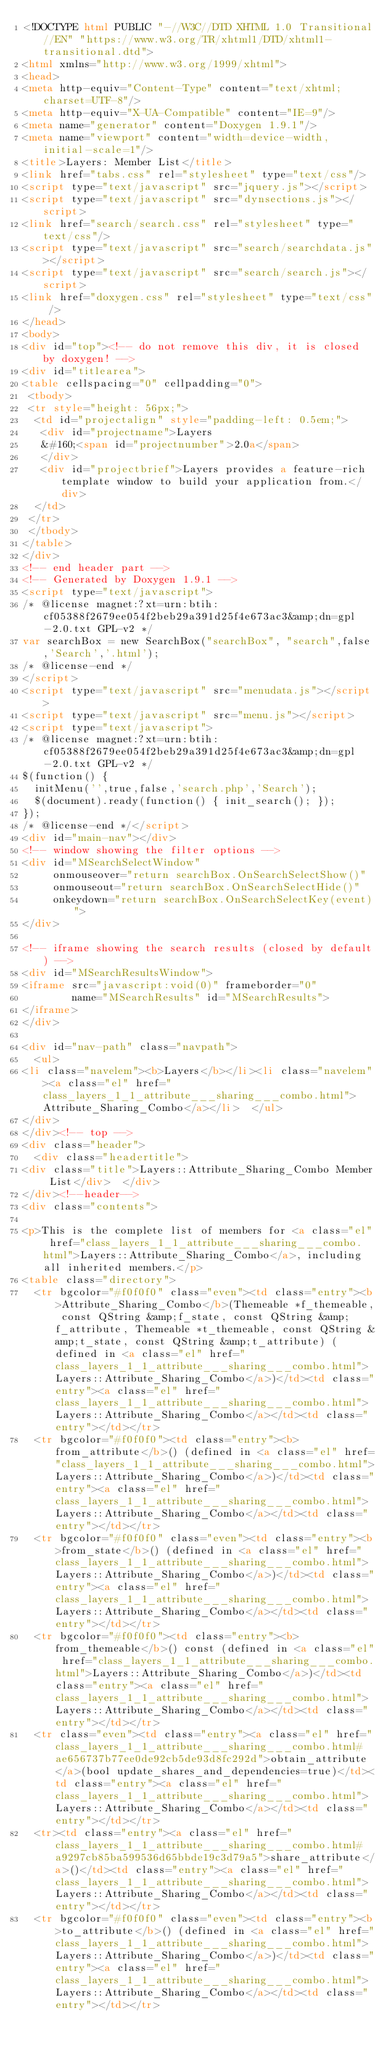Convert code to text. <code><loc_0><loc_0><loc_500><loc_500><_HTML_><!DOCTYPE html PUBLIC "-//W3C//DTD XHTML 1.0 Transitional//EN" "https://www.w3.org/TR/xhtml1/DTD/xhtml1-transitional.dtd">
<html xmlns="http://www.w3.org/1999/xhtml">
<head>
<meta http-equiv="Content-Type" content="text/xhtml;charset=UTF-8"/>
<meta http-equiv="X-UA-Compatible" content="IE=9"/>
<meta name="generator" content="Doxygen 1.9.1"/>
<meta name="viewport" content="width=device-width, initial-scale=1"/>
<title>Layers: Member List</title>
<link href="tabs.css" rel="stylesheet" type="text/css"/>
<script type="text/javascript" src="jquery.js"></script>
<script type="text/javascript" src="dynsections.js"></script>
<link href="search/search.css" rel="stylesheet" type="text/css"/>
<script type="text/javascript" src="search/searchdata.js"></script>
<script type="text/javascript" src="search/search.js"></script>
<link href="doxygen.css" rel="stylesheet" type="text/css" />
</head>
<body>
<div id="top"><!-- do not remove this div, it is closed by doxygen! -->
<div id="titlearea">
<table cellspacing="0" cellpadding="0">
 <tbody>
 <tr style="height: 56px;">
  <td id="projectalign" style="padding-left: 0.5em;">
   <div id="projectname">Layers
   &#160;<span id="projectnumber">2.0a</span>
   </div>
   <div id="projectbrief">Layers provides a feature-rich template window to build your application from.</div>
  </td>
 </tr>
 </tbody>
</table>
</div>
<!-- end header part -->
<!-- Generated by Doxygen 1.9.1 -->
<script type="text/javascript">
/* @license magnet:?xt=urn:btih:cf05388f2679ee054f2beb29a391d25f4e673ac3&amp;dn=gpl-2.0.txt GPL-v2 */
var searchBox = new SearchBox("searchBox", "search",false,'Search','.html');
/* @license-end */
</script>
<script type="text/javascript" src="menudata.js"></script>
<script type="text/javascript" src="menu.js"></script>
<script type="text/javascript">
/* @license magnet:?xt=urn:btih:cf05388f2679ee054f2beb29a391d25f4e673ac3&amp;dn=gpl-2.0.txt GPL-v2 */
$(function() {
  initMenu('',true,false,'search.php','Search');
  $(document).ready(function() { init_search(); });
});
/* @license-end */</script>
<div id="main-nav"></div>
<!-- window showing the filter options -->
<div id="MSearchSelectWindow"
     onmouseover="return searchBox.OnSearchSelectShow()"
     onmouseout="return searchBox.OnSearchSelectHide()"
     onkeydown="return searchBox.OnSearchSelectKey(event)">
</div>

<!-- iframe showing the search results (closed by default) -->
<div id="MSearchResultsWindow">
<iframe src="javascript:void(0)" frameborder="0" 
        name="MSearchResults" id="MSearchResults">
</iframe>
</div>

<div id="nav-path" class="navpath">
  <ul>
<li class="navelem"><b>Layers</b></li><li class="navelem"><a class="el" href="class_layers_1_1_attribute___sharing___combo.html">Attribute_Sharing_Combo</a></li>  </ul>
</div>
</div><!-- top -->
<div class="header">
  <div class="headertitle">
<div class="title">Layers::Attribute_Sharing_Combo Member List</div>  </div>
</div><!--header-->
<div class="contents">

<p>This is the complete list of members for <a class="el" href="class_layers_1_1_attribute___sharing___combo.html">Layers::Attribute_Sharing_Combo</a>, including all inherited members.</p>
<table class="directory">
  <tr bgcolor="#f0f0f0" class="even"><td class="entry"><b>Attribute_Sharing_Combo</b>(Themeable *f_themeable, const QString &amp;f_state, const QString &amp;f_attribute, Themeable *t_themeable, const QString &amp;t_state, const QString &amp;t_attribute) (defined in <a class="el" href="class_layers_1_1_attribute___sharing___combo.html">Layers::Attribute_Sharing_Combo</a>)</td><td class="entry"><a class="el" href="class_layers_1_1_attribute___sharing___combo.html">Layers::Attribute_Sharing_Combo</a></td><td class="entry"></td></tr>
  <tr bgcolor="#f0f0f0"><td class="entry"><b>from_attribute</b>() (defined in <a class="el" href="class_layers_1_1_attribute___sharing___combo.html">Layers::Attribute_Sharing_Combo</a>)</td><td class="entry"><a class="el" href="class_layers_1_1_attribute___sharing___combo.html">Layers::Attribute_Sharing_Combo</a></td><td class="entry"></td></tr>
  <tr bgcolor="#f0f0f0" class="even"><td class="entry"><b>from_state</b>() (defined in <a class="el" href="class_layers_1_1_attribute___sharing___combo.html">Layers::Attribute_Sharing_Combo</a>)</td><td class="entry"><a class="el" href="class_layers_1_1_attribute___sharing___combo.html">Layers::Attribute_Sharing_Combo</a></td><td class="entry"></td></tr>
  <tr bgcolor="#f0f0f0"><td class="entry"><b>from_themeable</b>() const (defined in <a class="el" href="class_layers_1_1_attribute___sharing___combo.html">Layers::Attribute_Sharing_Combo</a>)</td><td class="entry"><a class="el" href="class_layers_1_1_attribute___sharing___combo.html">Layers::Attribute_Sharing_Combo</a></td><td class="entry"></td></tr>
  <tr class="even"><td class="entry"><a class="el" href="class_layers_1_1_attribute___sharing___combo.html#ae656737b77ee0de92cb5de93d8fc292d">obtain_attribute</a>(bool update_shares_and_dependencies=true)</td><td class="entry"><a class="el" href="class_layers_1_1_attribute___sharing___combo.html">Layers::Attribute_Sharing_Combo</a></td><td class="entry"></td></tr>
  <tr><td class="entry"><a class="el" href="class_layers_1_1_attribute___sharing___combo.html#a9297cb85ba599536d65bbde19c3d79a5">share_attribute</a>()</td><td class="entry"><a class="el" href="class_layers_1_1_attribute___sharing___combo.html">Layers::Attribute_Sharing_Combo</a></td><td class="entry"></td></tr>
  <tr bgcolor="#f0f0f0" class="even"><td class="entry"><b>to_attribute</b>() (defined in <a class="el" href="class_layers_1_1_attribute___sharing___combo.html">Layers::Attribute_Sharing_Combo</a>)</td><td class="entry"><a class="el" href="class_layers_1_1_attribute___sharing___combo.html">Layers::Attribute_Sharing_Combo</a></td><td class="entry"></td></tr></code> 